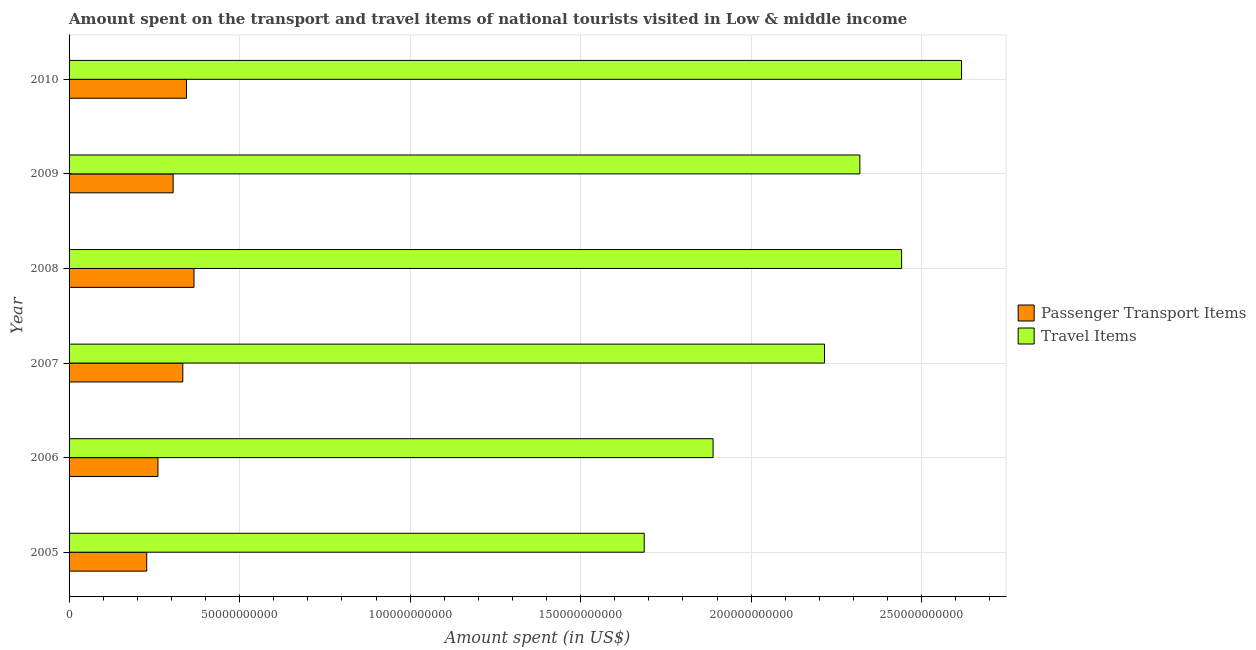How many different coloured bars are there?
Provide a succinct answer. 2. Are the number of bars per tick equal to the number of legend labels?
Make the answer very short. Yes. How many bars are there on the 4th tick from the top?
Give a very brief answer. 2. How many bars are there on the 4th tick from the bottom?
Your answer should be compact. 2. In how many cases, is the number of bars for a given year not equal to the number of legend labels?
Your response must be concise. 0. What is the amount spent in travel items in 2005?
Your answer should be compact. 1.69e+11. Across all years, what is the maximum amount spent in travel items?
Ensure brevity in your answer.  2.62e+11. Across all years, what is the minimum amount spent on passenger transport items?
Your answer should be very brief. 2.28e+1. In which year was the amount spent in travel items maximum?
Your answer should be very brief. 2010. In which year was the amount spent in travel items minimum?
Make the answer very short. 2005. What is the total amount spent on passenger transport items in the graph?
Your answer should be very brief. 1.84e+11. What is the difference between the amount spent in travel items in 2008 and that in 2010?
Provide a succinct answer. -1.76e+1. What is the difference between the amount spent in travel items in 2006 and the amount spent on passenger transport items in 2007?
Your answer should be very brief. 1.55e+11. What is the average amount spent on passenger transport items per year?
Ensure brevity in your answer.  3.06e+1. In the year 2008, what is the difference between the amount spent on passenger transport items and amount spent in travel items?
Your response must be concise. -2.07e+11. What is the ratio of the amount spent on passenger transport items in 2005 to that in 2010?
Ensure brevity in your answer.  0.66. Is the amount spent on passenger transport items in 2006 less than that in 2010?
Offer a very short reply. Yes. Is the difference between the amount spent on passenger transport items in 2005 and 2009 greater than the difference between the amount spent in travel items in 2005 and 2009?
Ensure brevity in your answer.  Yes. What is the difference between the highest and the second highest amount spent on passenger transport items?
Offer a very short reply. 2.21e+09. What is the difference between the highest and the lowest amount spent in travel items?
Make the answer very short. 9.30e+1. In how many years, is the amount spent in travel items greater than the average amount spent in travel items taken over all years?
Ensure brevity in your answer.  4. What does the 1st bar from the top in 2007 represents?
Ensure brevity in your answer.  Travel Items. What does the 2nd bar from the bottom in 2009 represents?
Provide a short and direct response. Travel Items. How many bars are there?
Offer a terse response. 12. Are all the bars in the graph horizontal?
Offer a very short reply. Yes. Are the values on the major ticks of X-axis written in scientific E-notation?
Provide a short and direct response. No. Does the graph contain any zero values?
Provide a short and direct response. No. How many legend labels are there?
Give a very brief answer. 2. What is the title of the graph?
Give a very brief answer. Amount spent on the transport and travel items of national tourists visited in Low & middle income. Does "Goods and services" appear as one of the legend labels in the graph?
Your answer should be very brief. No. What is the label or title of the X-axis?
Your answer should be very brief. Amount spent (in US$). What is the label or title of the Y-axis?
Your answer should be very brief. Year. What is the Amount spent (in US$) in Passenger Transport Items in 2005?
Keep it short and to the point. 2.28e+1. What is the Amount spent (in US$) of Travel Items in 2005?
Provide a succinct answer. 1.69e+11. What is the Amount spent (in US$) in Passenger Transport Items in 2006?
Provide a short and direct response. 2.61e+1. What is the Amount spent (in US$) in Travel Items in 2006?
Your response must be concise. 1.89e+11. What is the Amount spent (in US$) of Passenger Transport Items in 2007?
Provide a short and direct response. 3.34e+1. What is the Amount spent (in US$) of Travel Items in 2007?
Provide a succinct answer. 2.22e+11. What is the Amount spent (in US$) in Passenger Transport Items in 2008?
Offer a very short reply. 3.66e+1. What is the Amount spent (in US$) in Travel Items in 2008?
Offer a very short reply. 2.44e+11. What is the Amount spent (in US$) of Passenger Transport Items in 2009?
Give a very brief answer. 3.05e+1. What is the Amount spent (in US$) in Travel Items in 2009?
Your answer should be very brief. 2.32e+11. What is the Amount spent (in US$) of Passenger Transport Items in 2010?
Keep it short and to the point. 3.44e+1. What is the Amount spent (in US$) of Travel Items in 2010?
Provide a succinct answer. 2.62e+11. Across all years, what is the maximum Amount spent (in US$) in Passenger Transport Items?
Ensure brevity in your answer.  3.66e+1. Across all years, what is the maximum Amount spent (in US$) in Travel Items?
Keep it short and to the point. 2.62e+11. Across all years, what is the minimum Amount spent (in US$) in Passenger Transport Items?
Your response must be concise. 2.28e+1. Across all years, what is the minimum Amount spent (in US$) in Travel Items?
Your answer should be very brief. 1.69e+11. What is the total Amount spent (in US$) in Passenger Transport Items in the graph?
Offer a terse response. 1.84e+11. What is the total Amount spent (in US$) in Travel Items in the graph?
Keep it short and to the point. 1.32e+12. What is the difference between the Amount spent (in US$) in Passenger Transport Items in 2005 and that in 2006?
Your answer should be compact. -3.30e+09. What is the difference between the Amount spent (in US$) of Travel Items in 2005 and that in 2006?
Ensure brevity in your answer.  -2.02e+1. What is the difference between the Amount spent (in US$) in Passenger Transport Items in 2005 and that in 2007?
Your answer should be very brief. -1.06e+1. What is the difference between the Amount spent (in US$) of Travel Items in 2005 and that in 2007?
Provide a short and direct response. -5.29e+1. What is the difference between the Amount spent (in US$) of Passenger Transport Items in 2005 and that in 2008?
Ensure brevity in your answer.  -1.39e+1. What is the difference between the Amount spent (in US$) of Travel Items in 2005 and that in 2008?
Your response must be concise. -7.55e+1. What is the difference between the Amount spent (in US$) of Passenger Transport Items in 2005 and that in 2009?
Provide a short and direct response. -7.75e+09. What is the difference between the Amount spent (in US$) of Travel Items in 2005 and that in 2009?
Make the answer very short. -6.32e+1. What is the difference between the Amount spent (in US$) in Passenger Transport Items in 2005 and that in 2010?
Your answer should be compact. -1.17e+1. What is the difference between the Amount spent (in US$) in Travel Items in 2005 and that in 2010?
Your answer should be compact. -9.30e+1. What is the difference between the Amount spent (in US$) in Passenger Transport Items in 2006 and that in 2007?
Provide a short and direct response. -7.29e+09. What is the difference between the Amount spent (in US$) in Travel Items in 2006 and that in 2007?
Offer a terse response. -3.27e+1. What is the difference between the Amount spent (in US$) in Passenger Transport Items in 2006 and that in 2008?
Your answer should be very brief. -1.06e+1. What is the difference between the Amount spent (in US$) in Travel Items in 2006 and that in 2008?
Make the answer very short. -5.53e+1. What is the difference between the Amount spent (in US$) in Passenger Transport Items in 2006 and that in 2009?
Offer a terse response. -4.45e+09. What is the difference between the Amount spent (in US$) of Travel Items in 2006 and that in 2009?
Give a very brief answer. -4.30e+1. What is the difference between the Amount spent (in US$) of Passenger Transport Items in 2006 and that in 2010?
Make the answer very short. -8.36e+09. What is the difference between the Amount spent (in US$) of Travel Items in 2006 and that in 2010?
Your answer should be compact. -7.28e+1. What is the difference between the Amount spent (in US$) in Passenger Transport Items in 2007 and that in 2008?
Offer a very short reply. -3.28e+09. What is the difference between the Amount spent (in US$) of Travel Items in 2007 and that in 2008?
Make the answer very short. -2.26e+1. What is the difference between the Amount spent (in US$) of Passenger Transport Items in 2007 and that in 2009?
Keep it short and to the point. 2.84e+09. What is the difference between the Amount spent (in US$) in Travel Items in 2007 and that in 2009?
Offer a terse response. -1.04e+1. What is the difference between the Amount spent (in US$) in Passenger Transport Items in 2007 and that in 2010?
Ensure brevity in your answer.  -1.07e+09. What is the difference between the Amount spent (in US$) in Travel Items in 2007 and that in 2010?
Offer a very short reply. -4.02e+1. What is the difference between the Amount spent (in US$) in Passenger Transport Items in 2008 and that in 2009?
Give a very brief answer. 6.11e+09. What is the difference between the Amount spent (in US$) of Travel Items in 2008 and that in 2009?
Offer a terse response. 1.22e+1. What is the difference between the Amount spent (in US$) in Passenger Transport Items in 2008 and that in 2010?
Ensure brevity in your answer.  2.21e+09. What is the difference between the Amount spent (in US$) in Travel Items in 2008 and that in 2010?
Your answer should be very brief. -1.76e+1. What is the difference between the Amount spent (in US$) in Passenger Transport Items in 2009 and that in 2010?
Provide a succinct answer. -3.91e+09. What is the difference between the Amount spent (in US$) in Travel Items in 2009 and that in 2010?
Provide a short and direct response. -2.98e+1. What is the difference between the Amount spent (in US$) of Passenger Transport Items in 2005 and the Amount spent (in US$) of Travel Items in 2006?
Ensure brevity in your answer.  -1.66e+11. What is the difference between the Amount spent (in US$) in Passenger Transport Items in 2005 and the Amount spent (in US$) in Travel Items in 2007?
Make the answer very short. -1.99e+11. What is the difference between the Amount spent (in US$) in Passenger Transport Items in 2005 and the Amount spent (in US$) in Travel Items in 2008?
Make the answer very short. -2.21e+11. What is the difference between the Amount spent (in US$) of Passenger Transport Items in 2005 and the Amount spent (in US$) of Travel Items in 2009?
Your response must be concise. -2.09e+11. What is the difference between the Amount spent (in US$) of Passenger Transport Items in 2005 and the Amount spent (in US$) of Travel Items in 2010?
Ensure brevity in your answer.  -2.39e+11. What is the difference between the Amount spent (in US$) in Passenger Transport Items in 2006 and the Amount spent (in US$) in Travel Items in 2007?
Offer a terse response. -1.95e+11. What is the difference between the Amount spent (in US$) in Passenger Transport Items in 2006 and the Amount spent (in US$) in Travel Items in 2008?
Your answer should be compact. -2.18e+11. What is the difference between the Amount spent (in US$) in Passenger Transport Items in 2006 and the Amount spent (in US$) in Travel Items in 2009?
Provide a succinct answer. -2.06e+11. What is the difference between the Amount spent (in US$) of Passenger Transport Items in 2006 and the Amount spent (in US$) of Travel Items in 2010?
Your answer should be compact. -2.36e+11. What is the difference between the Amount spent (in US$) of Passenger Transport Items in 2007 and the Amount spent (in US$) of Travel Items in 2008?
Keep it short and to the point. -2.11e+11. What is the difference between the Amount spent (in US$) of Passenger Transport Items in 2007 and the Amount spent (in US$) of Travel Items in 2009?
Give a very brief answer. -1.99e+11. What is the difference between the Amount spent (in US$) of Passenger Transport Items in 2007 and the Amount spent (in US$) of Travel Items in 2010?
Offer a very short reply. -2.28e+11. What is the difference between the Amount spent (in US$) in Passenger Transport Items in 2008 and the Amount spent (in US$) in Travel Items in 2009?
Provide a short and direct response. -1.95e+11. What is the difference between the Amount spent (in US$) in Passenger Transport Items in 2008 and the Amount spent (in US$) in Travel Items in 2010?
Keep it short and to the point. -2.25e+11. What is the difference between the Amount spent (in US$) of Passenger Transport Items in 2009 and the Amount spent (in US$) of Travel Items in 2010?
Offer a very short reply. -2.31e+11. What is the average Amount spent (in US$) of Passenger Transport Items per year?
Provide a succinct answer. 3.06e+1. What is the average Amount spent (in US$) of Travel Items per year?
Give a very brief answer. 2.19e+11. In the year 2005, what is the difference between the Amount spent (in US$) of Passenger Transport Items and Amount spent (in US$) of Travel Items?
Offer a terse response. -1.46e+11. In the year 2006, what is the difference between the Amount spent (in US$) of Passenger Transport Items and Amount spent (in US$) of Travel Items?
Your response must be concise. -1.63e+11. In the year 2007, what is the difference between the Amount spent (in US$) in Passenger Transport Items and Amount spent (in US$) in Travel Items?
Give a very brief answer. -1.88e+11. In the year 2008, what is the difference between the Amount spent (in US$) in Passenger Transport Items and Amount spent (in US$) in Travel Items?
Your answer should be compact. -2.07e+11. In the year 2009, what is the difference between the Amount spent (in US$) in Passenger Transport Items and Amount spent (in US$) in Travel Items?
Offer a very short reply. -2.01e+11. In the year 2010, what is the difference between the Amount spent (in US$) of Passenger Transport Items and Amount spent (in US$) of Travel Items?
Offer a terse response. -2.27e+11. What is the ratio of the Amount spent (in US$) in Passenger Transport Items in 2005 to that in 2006?
Ensure brevity in your answer.  0.87. What is the ratio of the Amount spent (in US$) in Travel Items in 2005 to that in 2006?
Provide a short and direct response. 0.89. What is the ratio of the Amount spent (in US$) in Passenger Transport Items in 2005 to that in 2007?
Your response must be concise. 0.68. What is the ratio of the Amount spent (in US$) of Travel Items in 2005 to that in 2007?
Keep it short and to the point. 0.76. What is the ratio of the Amount spent (in US$) of Passenger Transport Items in 2005 to that in 2008?
Provide a short and direct response. 0.62. What is the ratio of the Amount spent (in US$) of Travel Items in 2005 to that in 2008?
Your answer should be compact. 0.69. What is the ratio of the Amount spent (in US$) of Passenger Transport Items in 2005 to that in 2009?
Your answer should be very brief. 0.75. What is the ratio of the Amount spent (in US$) in Travel Items in 2005 to that in 2009?
Give a very brief answer. 0.73. What is the ratio of the Amount spent (in US$) in Passenger Transport Items in 2005 to that in 2010?
Offer a very short reply. 0.66. What is the ratio of the Amount spent (in US$) in Travel Items in 2005 to that in 2010?
Give a very brief answer. 0.64. What is the ratio of the Amount spent (in US$) of Passenger Transport Items in 2006 to that in 2007?
Ensure brevity in your answer.  0.78. What is the ratio of the Amount spent (in US$) in Travel Items in 2006 to that in 2007?
Make the answer very short. 0.85. What is the ratio of the Amount spent (in US$) in Passenger Transport Items in 2006 to that in 2008?
Your answer should be compact. 0.71. What is the ratio of the Amount spent (in US$) of Travel Items in 2006 to that in 2008?
Keep it short and to the point. 0.77. What is the ratio of the Amount spent (in US$) of Passenger Transport Items in 2006 to that in 2009?
Offer a very short reply. 0.85. What is the ratio of the Amount spent (in US$) in Travel Items in 2006 to that in 2009?
Your answer should be compact. 0.81. What is the ratio of the Amount spent (in US$) in Passenger Transport Items in 2006 to that in 2010?
Offer a terse response. 0.76. What is the ratio of the Amount spent (in US$) in Travel Items in 2006 to that in 2010?
Keep it short and to the point. 0.72. What is the ratio of the Amount spent (in US$) in Passenger Transport Items in 2007 to that in 2008?
Provide a succinct answer. 0.91. What is the ratio of the Amount spent (in US$) in Travel Items in 2007 to that in 2008?
Your answer should be compact. 0.91. What is the ratio of the Amount spent (in US$) of Passenger Transport Items in 2007 to that in 2009?
Make the answer very short. 1.09. What is the ratio of the Amount spent (in US$) in Travel Items in 2007 to that in 2009?
Offer a very short reply. 0.96. What is the ratio of the Amount spent (in US$) in Passenger Transport Items in 2007 to that in 2010?
Offer a terse response. 0.97. What is the ratio of the Amount spent (in US$) of Travel Items in 2007 to that in 2010?
Your answer should be very brief. 0.85. What is the ratio of the Amount spent (in US$) of Passenger Transport Items in 2008 to that in 2009?
Your answer should be very brief. 1.2. What is the ratio of the Amount spent (in US$) in Travel Items in 2008 to that in 2009?
Provide a short and direct response. 1.05. What is the ratio of the Amount spent (in US$) of Passenger Transport Items in 2008 to that in 2010?
Offer a very short reply. 1.06. What is the ratio of the Amount spent (in US$) of Travel Items in 2008 to that in 2010?
Keep it short and to the point. 0.93. What is the ratio of the Amount spent (in US$) of Passenger Transport Items in 2009 to that in 2010?
Offer a terse response. 0.89. What is the ratio of the Amount spent (in US$) in Travel Items in 2009 to that in 2010?
Provide a succinct answer. 0.89. What is the difference between the highest and the second highest Amount spent (in US$) of Passenger Transport Items?
Give a very brief answer. 2.21e+09. What is the difference between the highest and the second highest Amount spent (in US$) in Travel Items?
Offer a terse response. 1.76e+1. What is the difference between the highest and the lowest Amount spent (in US$) in Passenger Transport Items?
Your response must be concise. 1.39e+1. What is the difference between the highest and the lowest Amount spent (in US$) in Travel Items?
Your answer should be compact. 9.30e+1. 